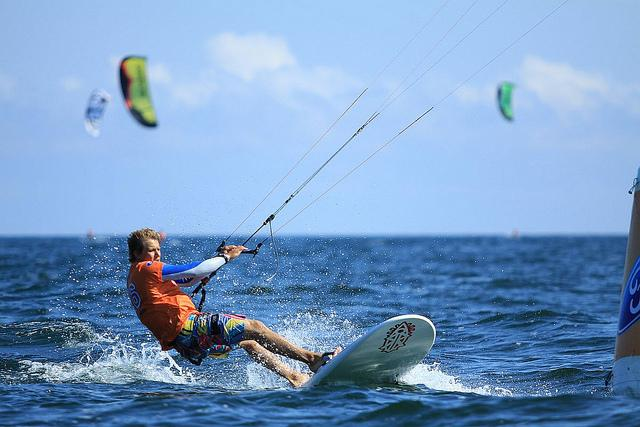The man who received the first patent for this sport was from which country? Please explain your reasoning. netherlands. The man who received the first patent was from a european country.  the netherlands would be the only answer to meet this criteria. 